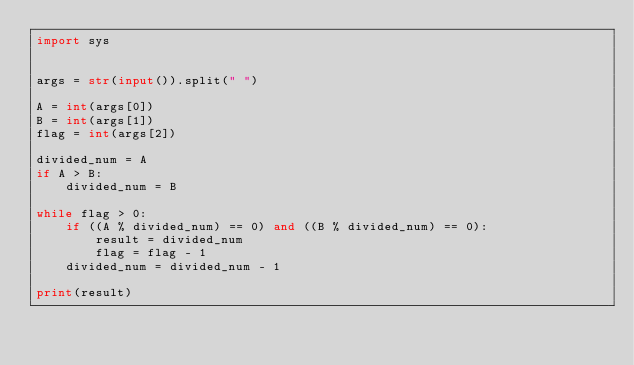Convert code to text. <code><loc_0><loc_0><loc_500><loc_500><_Python_>import sys


args = str(input()).split(" ")

A = int(args[0])
B = int(args[1])
flag = int(args[2])

divided_num = A
if A > B:
    divided_num = B

while flag > 0:
    if ((A % divided_num) == 0) and ((B % divided_num) == 0):
        result = divided_num
        flag = flag - 1
    divided_num = divided_num - 1

print(result)
</code> 